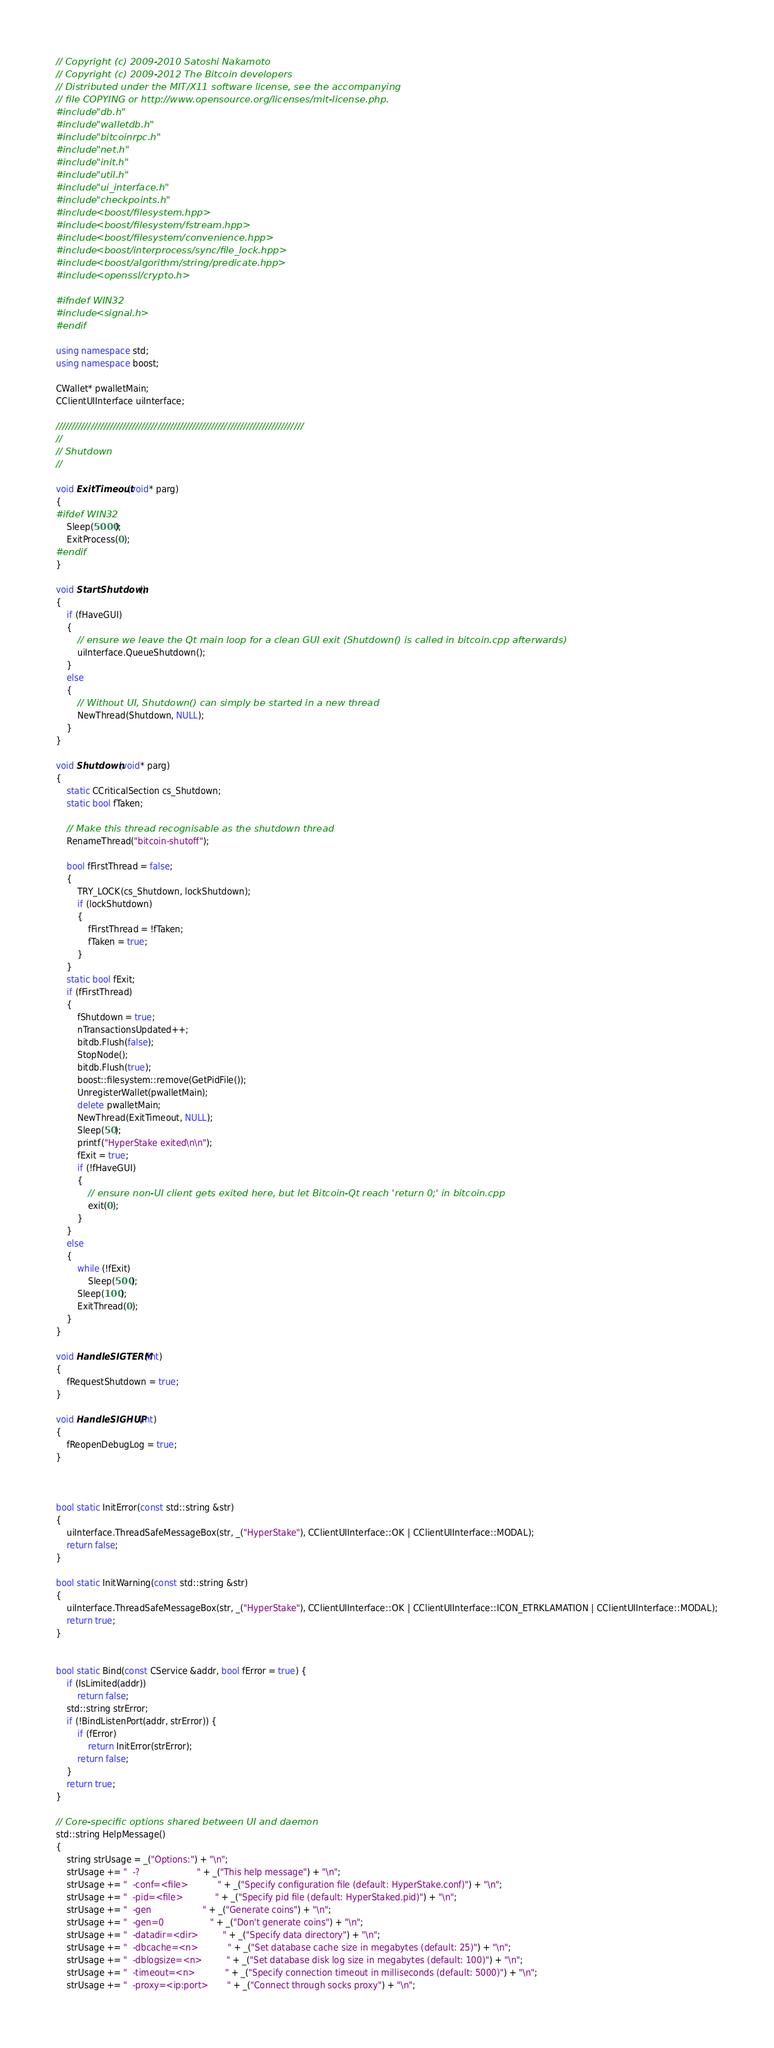Convert code to text. <code><loc_0><loc_0><loc_500><loc_500><_C++_>// Copyright (c) 2009-2010 Satoshi Nakamoto
// Copyright (c) 2009-2012 The Bitcoin developers
// Distributed under the MIT/X11 software license, see the accompanying
// file COPYING or http://www.opensource.org/licenses/mit-license.php.
#include "db.h"
#include "walletdb.h"
#include "bitcoinrpc.h"
#include "net.h"
#include "init.h"
#include "util.h"
#include "ui_interface.h"
#include "checkpoints.h"
#include <boost/filesystem.hpp>
#include <boost/filesystem/fstream.hpp>
#include <boost/filesystem/convenience.hpp>
#include <boost/interprocess/sync/file_lock.hpp>
#include <boost/algorithm/string/predicate.hpp>
#include <openssl/crypto.h>

#ifndef WIN32
#include <signal.h>
#endif

using namespace std;
using namespace boost;

CWallet* pwalletMain;
CClientUIInterface uiInterface;

//////////////////////////////////////////////////////////////////////////////
//
// Shutdown
//

void ExitTimeout(void* parg)
{
#ifdef WIN32
    Sleep(5000);
    ExitProcess(0);
#endif
}

void StartShutdown()
{
    if (fHaveGUI)
    {
        // ensure we leave the Qt main loop for a clean GUI exit (Shutdown() is called in bitcoin.cpp afterwards)
        uiInterface.QueueShutdown();
    }
    else
    {
        // Without UI, Shutdown() can simply be started in a new thread
        NewThread(Shutdown, NULL);
    }
}

void Shutdown(void* parg)
{
    static CCriticalSection cs_Shutdown;
    static bool fTaken;

    // Make this thread recognisable as the shutdown thread
    RenameThread("bitcoin-shutoff");

    bool fFirstThread = false;
    {
        TRY_LOCK(cs_Shutdown, lockShutdown);
        if (lockShutdown)
        {
            fFirstThread = !fTaken;
            fTaken = true;
        }
    }
    static bool fExit;
    if (fFirstThread)
    {
        fShutdown = true;
        nTransactionsUpdated++;
        bitdb.Flush(false);
        StopNode();
        bitdb.Flush(true);
        boost::filesystem::remove(GetPidFile());
        UnregisterWallet(pwalletMain);
        delete pwalletMain;
        NewThread(ExitTimeout, NULL);
        Sleep(50);
        printf("HyperStake exited\n\n");
        fExit = true;
        if (!fHaveGUI)
        {
            // ensure non-UI client gets exited here, but let Bitcoin-Qt reach 'return 0;' in bitcoin.cpp
            exit(0);
        }
    }
    else
    {
        while (!fExit)
            Sleep(500);
        Sleep(100);
        ExitThread(0);
    }
}

void HandleSIGTERM(int)
{
    fRequestShutdown = true;
}

void HandleSIGHUP(int)
{
    fReopenDebugLog = true;
}



bool static InitError(const std::string &str)
{
    uiInterface.ThreadSafeMessageBox(str, _("HyperStake"), CClientUIInterface::OK | CClientUIInterface::MODAL);
    return false;
}

bool static InitWarning(const std::string &str)
{
    uiInterface.ThreadSafeMessageBox(str, _("HyperStake"), CClientUIInterface::OK | CClientUIInterface::ICON_ETRKLAMATION | CClientUIInterface::MODAL);
    return true;
}


bool static Bind(const CService &addr, bool fError = true) {
    if (IsLimited(addr))
        return false;
    std::string strError;
    if (!BindListenPort(addr, strError)) {
        if (fError)
            return InitError(strError);
        return false;
    }
    return true;
}

// Core-specific options shared between UI and daemon
std::string HelpMessage()
{
    string strUsage = _("Options:") + "\n";
    strUsage += "  -?                     " + _("This help message") + "\n";
    strUsage += "  -conf=<file>           " + _("Specify configuration file (default: HyperStake.conf)") + "\n";
    strUsage += "  -pid=<file>            " + _("Specify pid file (default: HyperStaked.pid)") + "\n";
    strUsage += "  -gen                   " + _("Generate coins") + "\n";
    strUsage += "  -gen=0                 " + _("Don't generate coins") + "\n";
    strUsage += "  -datadir=<dir>         " + _("Specify data directory") + "\n";
    strUsage += "  -dbcache=<n>           " + _("Set database cache size in megabytes (default: 25)") + "\n";
    strUsage += "  -dblogsize=<n>         " + _("Set database disk log size in megabytes (default: 100)") + "\n";
    strUsage += "  -timeout=<n>           " + _("Specify connection timeout in milliseconds (default: 5000)") + "\n";
    strUsage += "  -proxy=<ip:port>       " + _("Connect through socks proxy") + "\n";</code> 